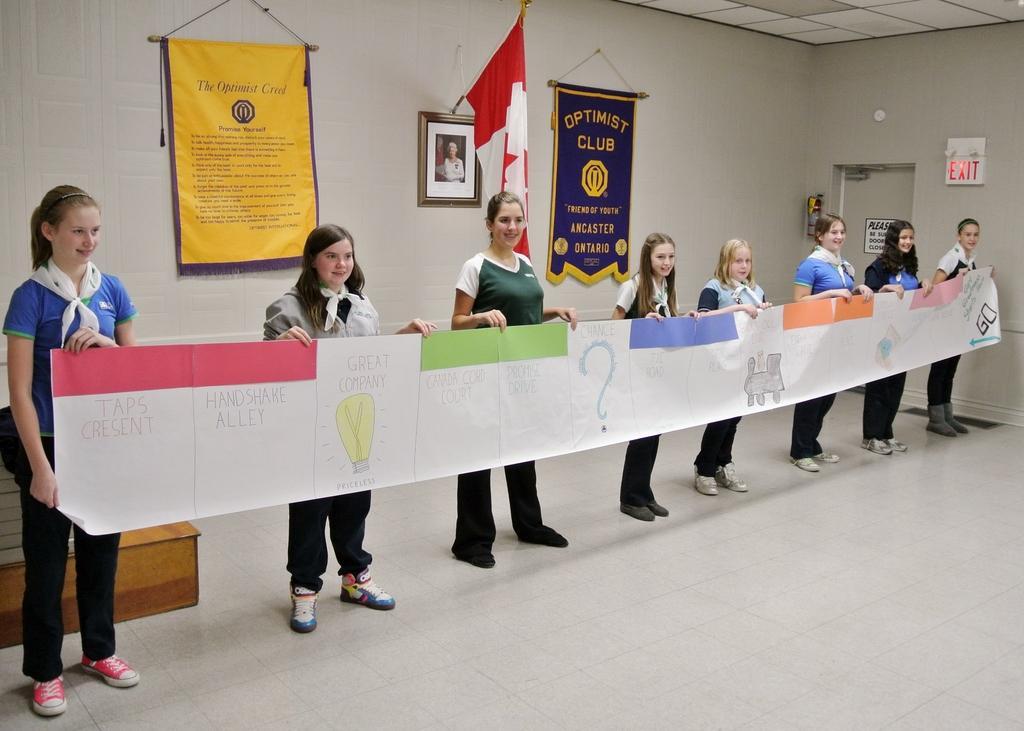In one or two sentences, can you explain what this image depicts? This picture is clicked inside the hall. In the center we can see the group of women wearing t-shirts, holding a banner and standing and we can see the text and some pictures on the banner. In the background we can see the flag and the picture frame hanging on the wall and we can see the text on the banners hanging on the wall, we can see the door and some other objects. At the top we can see the roof. 